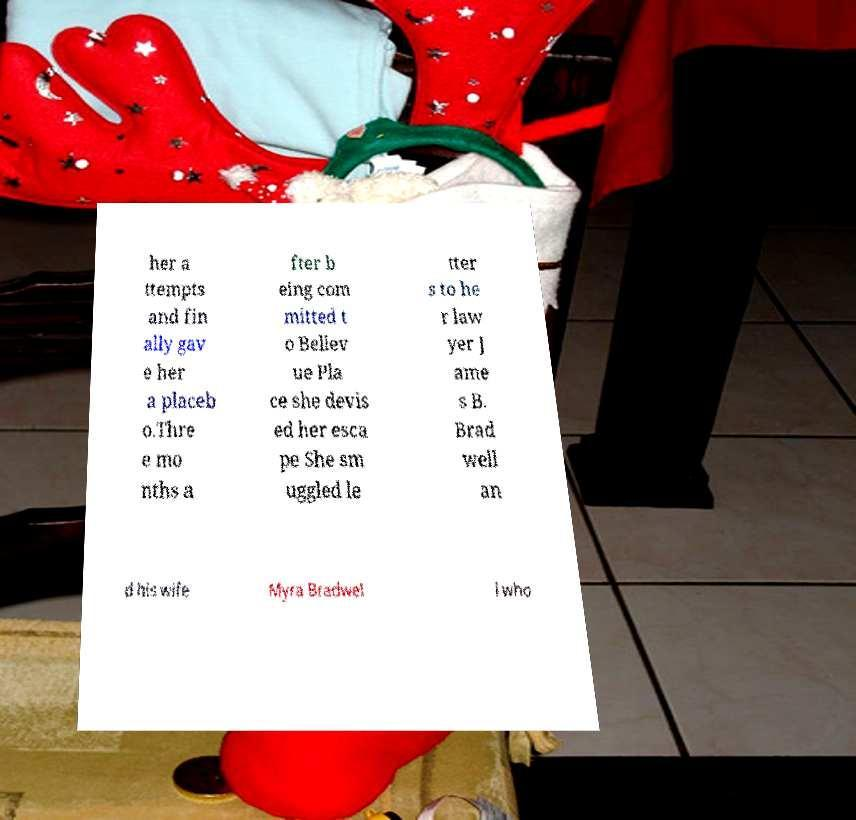Please identify and transcribe the text found in this image. her a ttempts and fin ally gav e her a placeb o.Thre e mo nths a fter b eing com mitted t o Bellev ue Pla ce she devis ed her esca pe She sm uggled le tter s to he r law yer J ame s B. Brad well an d his wife Myra Bradwel l who 